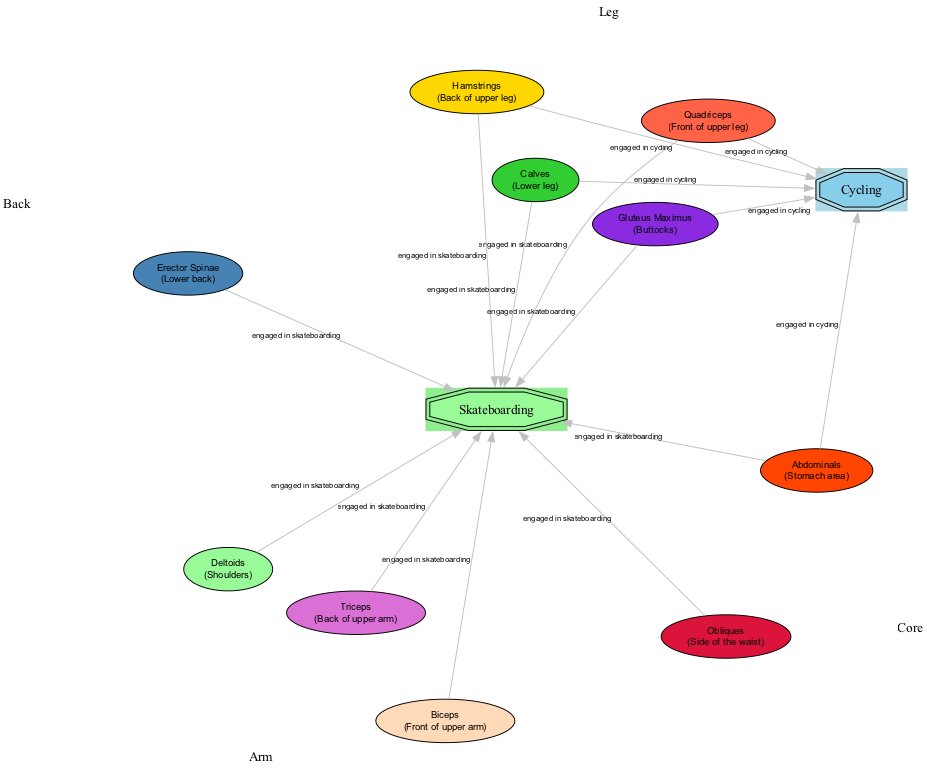What's the color code for the Quadriceps? The Quadriceps node in the diagram has a color code represented as #FF6347. This can be identified by looking at the node's properties in the data.
Answer: #FF6347 How many muscle groups are engaged in cycling? There are five nodes connected to cycling, which represent the muscle groups engaged in that activity. These are the Quadriceps, Hamstrings, Gluteus Maximus, Calves, and Abdominals. Counting these provides the answer.
Answer: 5 What is the primary muscle group in the front of the upper leg? The diagram labels the Quadriceps as being located at the front of the upper leg, thus identifying it as the primary muscle group in that area.
Answer: Quadriceps Which muscle group is responsible for engaging the side of the waist during skateboarding? The Obliques are listed in the diagram as being engaged in skateboarding and are specifically described as located on the side of the waist. This makes it the answer.
Answer: Obliques How many edges are connected to the skating node? By reviewing the edges connected to the skateboarding node, it is determined that there are six edges: towards the Quadriceps, Hamstrings, Gluteus Maximus, Calves, Abdominals, and the Erector Spinae along with three arm muscles (Biceps, Triceps, Deltoids). In total, there are eight edges connected to skateboarding as it also engages three additional muscle groups in the arms.
Answer: 8 Which muscle group is located in the lower back? The Erector Spinae is labeled in the diagram as being positioned in the lower back area. This is confirmed by checking the description associated with that node.
Answer: Erector Spinae Do both cycling and skateboarding engage the same muscle groups? Yes, both activities engage the same primary muscle groups of the Quadriceps, Hamstrings, Gluteus Maximus, Calves, and Abdominals. A comparison of the edges connected to cycling and skateboarding shows that these nodes are the same for both, indicating they activate the same muscles.
Answer: Yes What is the color of the Gluteus Maximus node? The color code for the Gluteus Maximus in the diagram is #8A2BE2. This can be confirmed by examining the node's information in the provided data collection.
Answer: #8A2BE2 Which muscle group works the front of the upper arm when skateboarding? The Biceps node is indicated in the diagram to represent the muscle group that works the front of the upper arm during skateboarding. This can be determined by locating the node and checking its description.
Answer: Biceps 